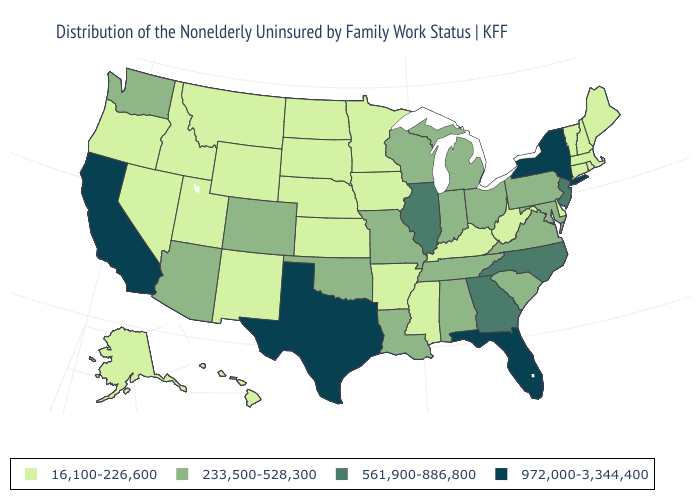Does West Virginia have the lowest value in the USA?
Short answer required. Yes. Name the states that have a value in the range 561,900-886,800?
Concise answer only. Georgia, Illinois, New Jersey, North Carolina. What is the value of Arizona?
Quick response, please. 233,500-528,300. What is the lowest value in states that border Tennessee?
Keep it brief. 16,100-226,600. Name the states that have a value in the range 972,000-3,344,400?
Give a very brief answer. California, Florida, New York, Texas. Does Wyoming have a lower value than Utah?
Concise answer only. No. Name the states that have a value in the range 972,000-3,344,400?
Concise answer only. California, Florida, New York, Texas. What is the value of Illinois?
Quick response, please. 561,900-886,800. Which states have the lowest value in the South?
Answer briefly. Arkansas, Delaware, Kentucky, Mississippi, West Virginia. Name the states that have a value in the range 561,900-886,800?
Keep it brief. Georgia, Illinois, New Jersey, North Carolina. What is the value of Mississippi?
Answer briefly. 16,100-226,600. Which states have the lowest value in the USA?
Concise answer only. Alaska, Arkansas, Connecticut, Delaware, Hawaii, Idaho, Iowa, Kansas, Kentucky, Maine, Massachusetts, Minnesota, Mississippi, Montana, Nebraska, Nevada, New Hampshire, New Mexico, North Dakota, Oregon, Rhode Island, South Dakota, Utah, Vermont, West Virginia, Wyoming. Which states have the lowest value in the USA?
Keep it brief. Alaska, Arkansas, Connecticut, Delaware, Hawaii, Idaho, Iowa, Kansas, Kentucky, Maine, Massachusetts, Minnesota, Mississippi, Montana, Nebraska, Nevada, New Hampshire, New Mexico, North Dakota, Oregon, Rhode Island, South Dakota, Utah, Vermont, West Virginia, Wyoming. Which states have the highest value in the USA?
Be succinct. California, Florida, New York, Texas. Does the map have missing data?
Give a very brief answer. No. 